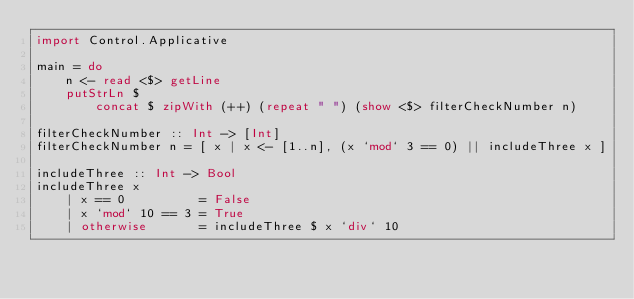<code> <loc_0><loc_0><loc_500><loc_500><_Haskell_>import Control.Applicative

main = do
    n <- read <$> getLine
    putStrLn $
        concat $ zipWith (++) (repeat " ") (show <$> filterCheckNumber n)

filterCheckNumber :: Int -> [Int]
filterCheckNumber n = [ x | x <- [1..n], (x `mod` 3 == 0) || includeThree x ]

includeThree :: Int -> Bool
includeThree x
    | x == 0          = False
    | x `mod` 10 == 3 = True
    | otherwise       = includeThree $ x `div` 10
</code> 